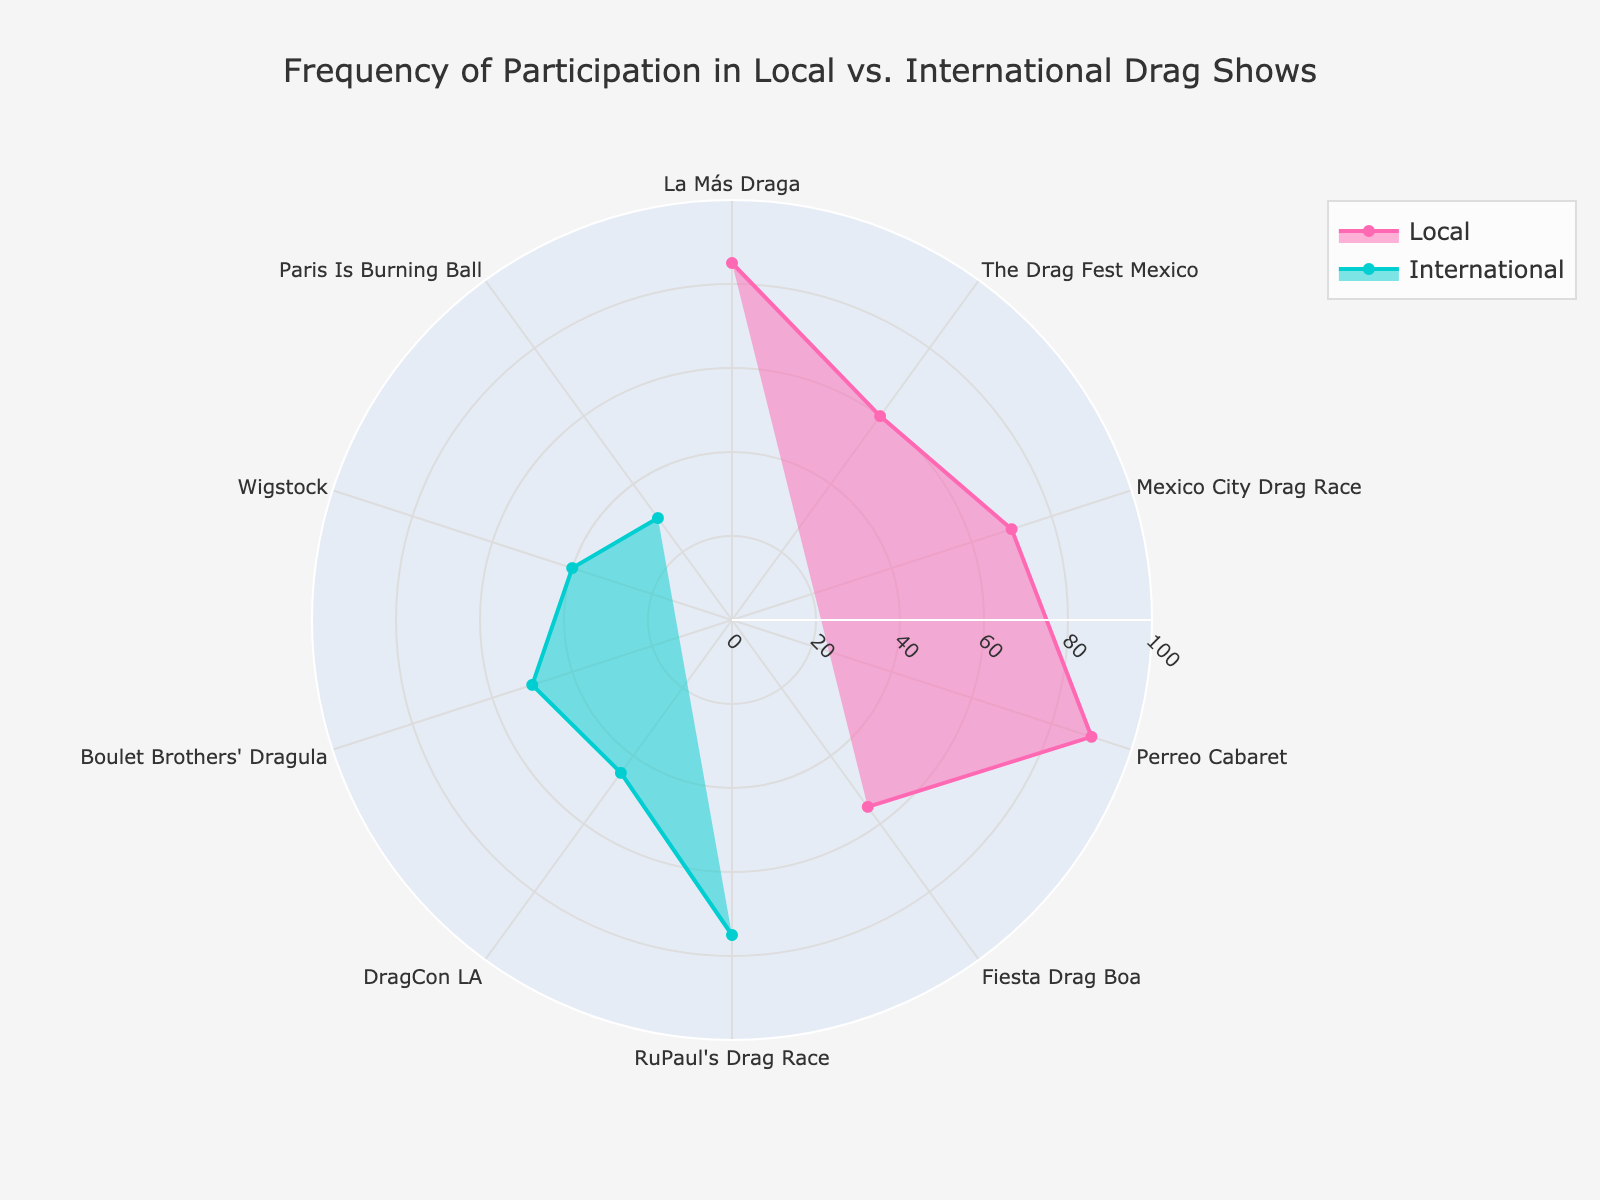what is the title of the plot? The title of the plot is located at the top and clearly labeled. The information is presented in the center above the figure.
Answer: Frequency of Participation in Local vs. International Drag Shows which color represents local drag shows? There are two types of drag shows: Local and International. The local drag shows are represented by pink color in both line and fill areas.
Answer: Pink which drag show has the highest participation frequency among locals? The local drag shows are plotted in pink. The drag show with the longest bar among the pink-colored traces indicates the highest participation frequency.
Answer: Perreo Cabaret what is the median participation frequency for international drag shows? To find the median value, sort the international frequencies and find the middle value. The frequencies are: 75, 45, 50, 40, 30. The middle value is 45 (the third value in the sorted list).
Answer: 45 are there more local or international drag shows represented? We count the number of data points for each category. Local shows are listed 5 times while international ones appear 5 times as well, making the counts equal.
Answer: Equal which local drag shows have a participation frequency greater than 60? We need to look at the pink-colored traces and identify the drag shows with frequencies above 60.
Answer: Perreo Cabaret, La Más Draga, Mexico City Drag Race how does the frequency of participation in La Más Draga compare with RuPaul's Drag Race? Locate and compare the lengths of the traces for La Más Draga and RuPaul's Drag Race. La Más Draga has a frequency of 85 while RuPaul's Drag Race has a frequency of 75, making La Más Draga higher.
Answer: La Más Draga is higher what is the average participation frequency of the local drag shows? Sum the frequencies of local shows and divide by the number of local shows: (85 + 60 + 70 + 90 + 55)/5.
Answer: 72 how many drag shows have a participation frequency below 50? Count the number of drag shows with a frequency below 50. For both categories combined: International (45, 40, 30) and Local (0 shows below 50).
Answer: 3 which international drag show has the lowest participation frequency? Look at the international drag shows and find the shortest trace which corresponds to the lowest frequency. The shortest trace is the Paris Is Burning Ball with a frequency of 30.
Answer: Paris Is Burning Ball 